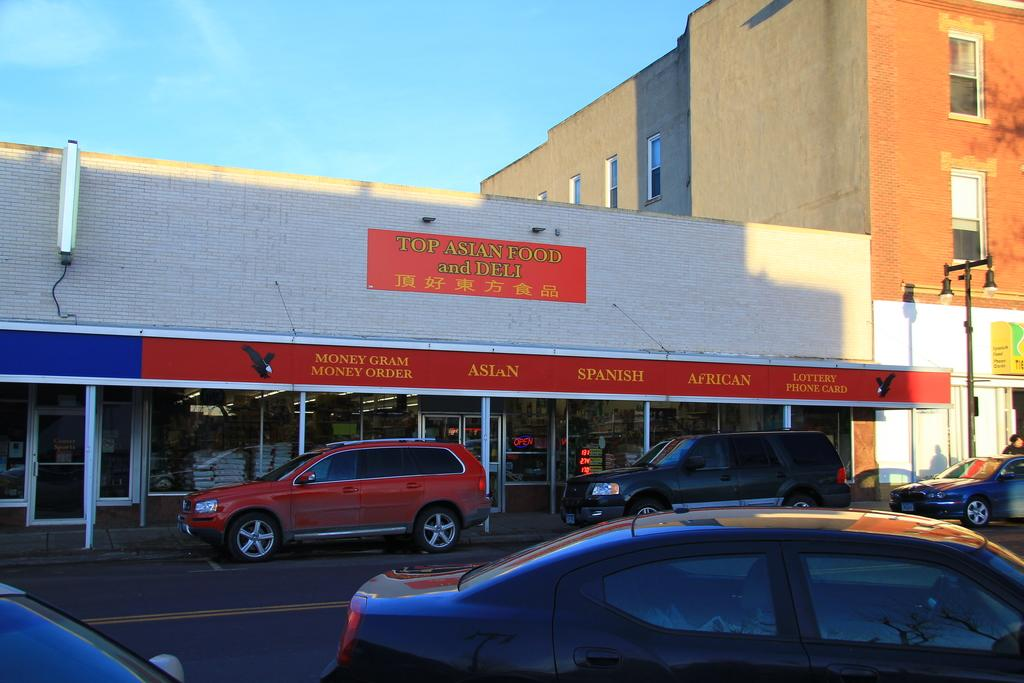What type of structures are visible in the image? There are buildings in the image. What feature do the buildings have? The buildings have windows. What are the light poles used for in the image? The light poles provide illumination in the image. What type of establishments can be found in the image? There are stores in the image. What type of doors are present in the image? There are glass doors in the image. What else can be seen in the image besides buildings and stores? There are poles and vehicles on the road in the image. What is the color of the sky in the image? The sky is blue in the image. Can you tell me how many quince are hanging from the light poles in the image? There are no quince present in the image; it features buildings, stores, and light poles. What type of detail can be seen on the glass doors in the image? The provided facts do not mention any specific details on the glass doors, so we cannot answer this question definitively. 